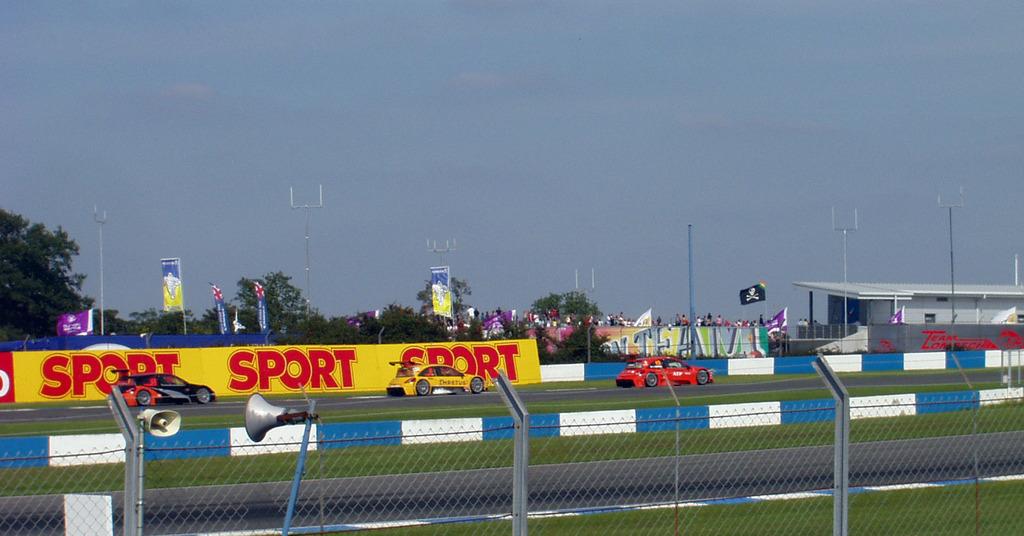What is written beside the word sport on the left?
Offer a very short reply. Sport. Sport sport sport?
Ensure brevity in your answer.  Yes. 